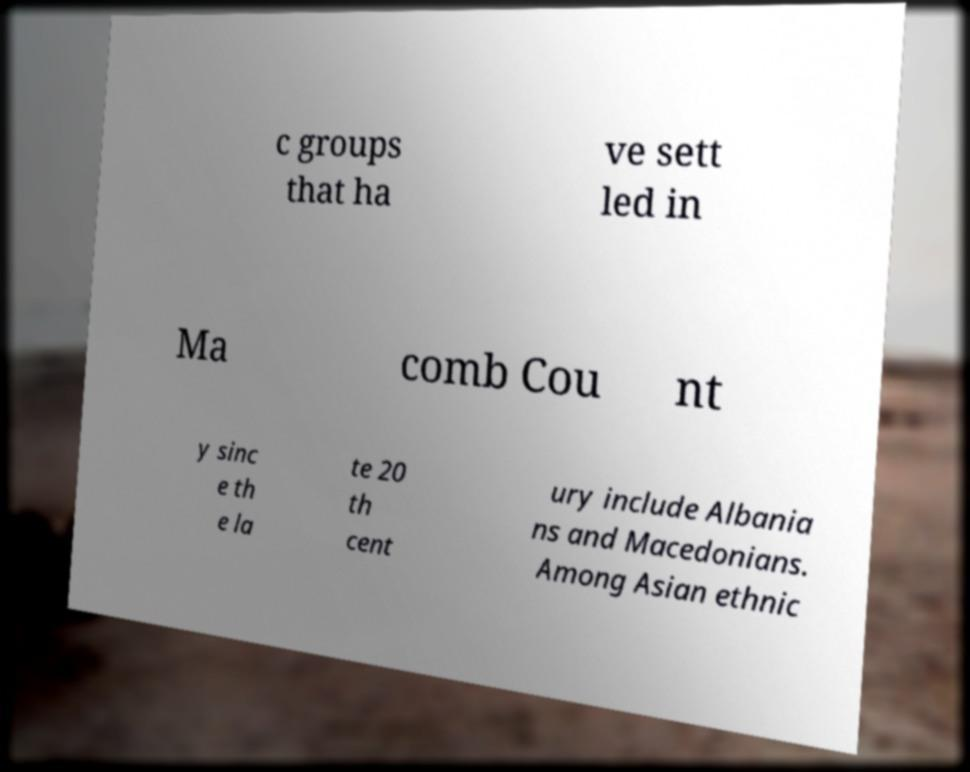Please identify and transcribe the text found in this image. c groups that ha ve sett led in Ma comb Cou nt y sinc e th e la te 20 th cent ury include Albania ns and Macedonians. Among Asian ethnic 